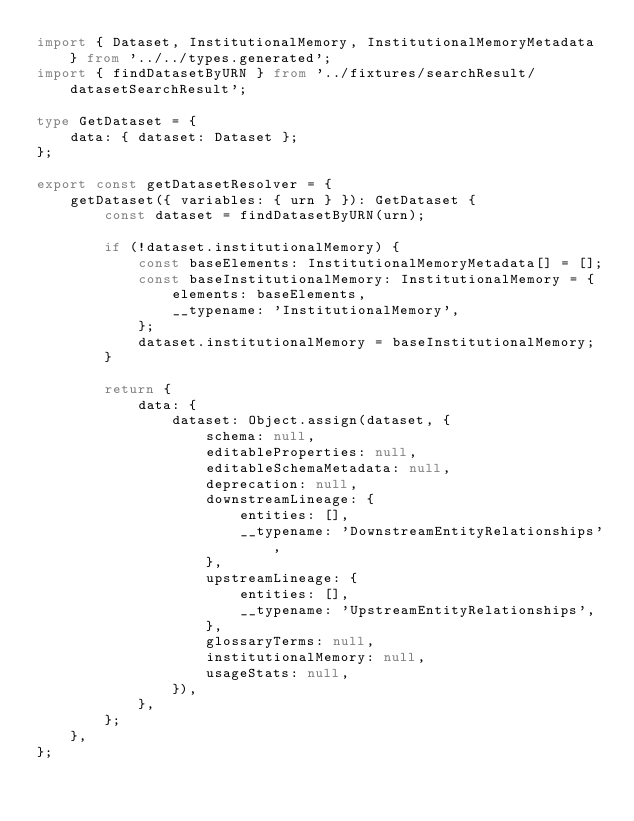<code> <loc_0><loc_0><loc_500><loc_500><_TypeScript_>import { Dataset, InstitutionalMemory, InstitutionalMemoryMetadata } from '../../types.generated';
import { findDatasetByURN } from '../fixtures/searchResult/datasetSearchResult';

type GetDataset = {
    data: { dataset: Dataset };
};

export const getDatasetResolver = {
    getDataset({ variables: { urn } }): GetDataset {
        const dataset = findDatasetByURN(urn);

        if (!dataset.institutionalMemory) {
            const baseElements: InstitutionalMemoryMetadata[] = [];
            const baseInstitutionalMemory: InstitutionalMemory = {
                elements: baseElements,
                __typename: 'InstitutionalMemory',
            };
            dataset.institutionalMemory = baseInstitutionalMemory;
        }

        return {
            data: {
                dataset: Object.assign(dataset, {
                    schema: null,
                    editableProperties: null,
                    editableSchemaMetadata: null,
                    deprecation: null,
                    downstreamLineage: {
                        entities: [],
                        __typename: 'DownstreamEntityRelationships',
                    },
                    upstreamLineage: {
                        entities: [],
                        __typename: 'UpstreamEntityRelationships',
                    },
                    glossaryTerms: null,
                    institutionalMemory: null,
                    usageStats: null,
                }),
            },
        };
    },
};
</code> 